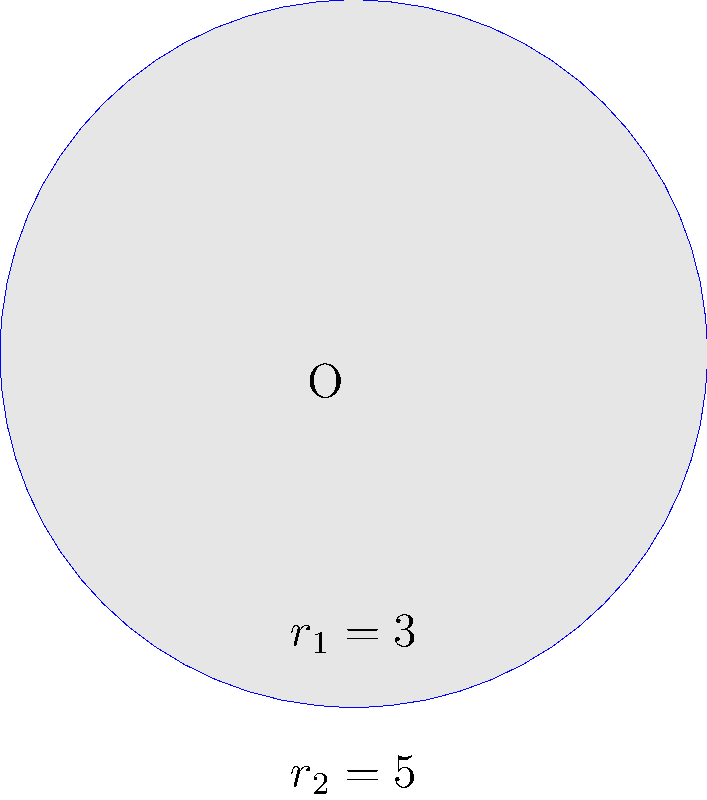In the spirit of harmony and interconnectedness, consider two concentric circles with radii $r_1 = 3$ units and $r_2 = 5$ units. Calculate the area of the region between these two circles, representing the space where different perspectives can coexist peacefully. To find the area between two concentric circles, we can follow these steps:

1. Calculate the area of the larger circle:
   $A_2 = \pi r_2^2 = \pi (5^2) = 25\pi$ square units

2. Calculate the area of the smaller circle:
   $A_1 = \pi r_1^2 = \pi (3^2) = 9\pi$ square units

3. The area between the circles is the difference between these two areas:
   $A_{between} = A_2 - A_1 = 25\pi - 9\pi = 16\pi$ square units

This approach embodies the Buddhist principle of finding truth through careful observation and logical reasoning.
Answer: $16\pi$ square units 